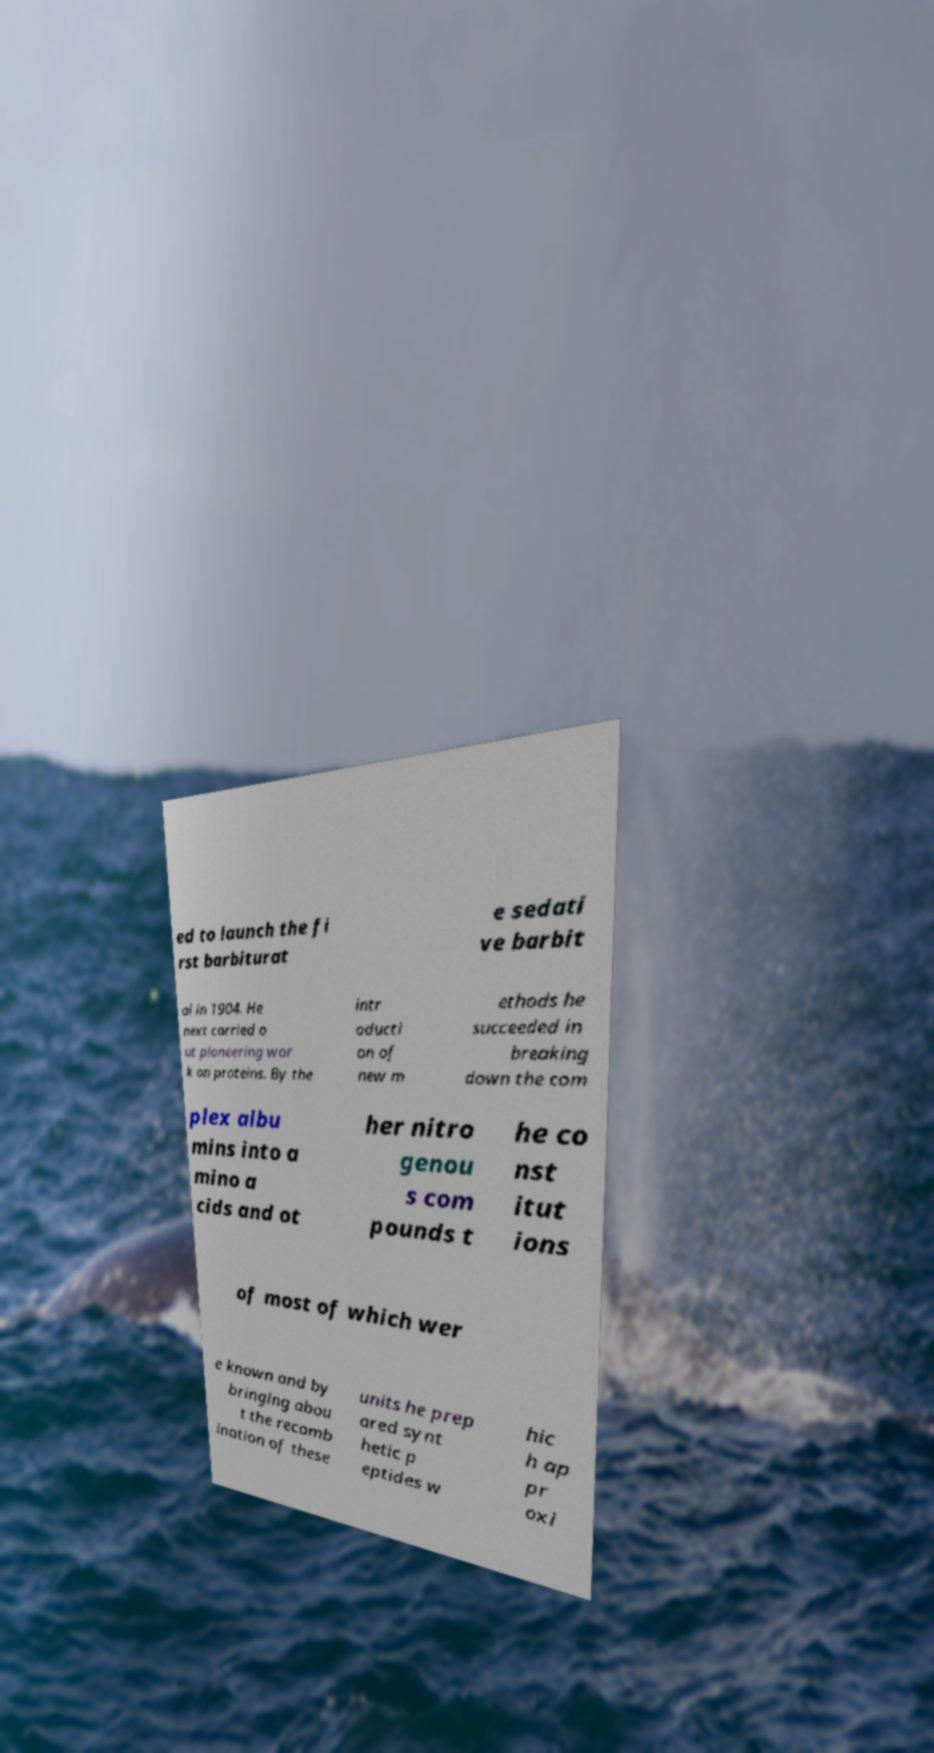There's text embedded in this image that I need extracted. Can you transcribe it verbatim? ed to launch the fi rst barbiturat e sedati ve barbit al in 1904. He next carried o ut pioneering wor k on proteins. By the intr oducti on of new m ethods he succeeded in breaking down the com plex albu mins into a mino a cids and ot her nitro genou s com pounds t he co nst itut ions of most of which wer e known and by bringing abou t the recomb ination of these units he prep ared synt hetic p eptides w hic h ap pr oxi 